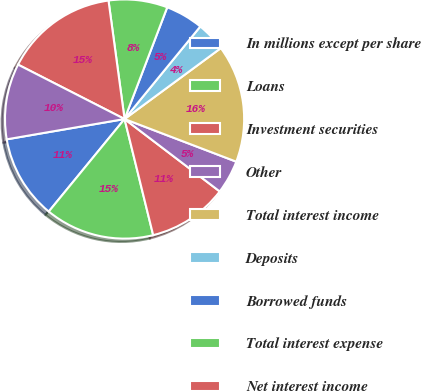<chart> <loc_0><loc_0><loc_500><loc_500><pie_chart><fcel>In millions except per share<fcel>Loans<fcel>Investment securities<fcel>Other<fcel>Total interest income<fcel>Deposits<fcel>Borrowed funds<fcel>Total interest expense<fcel>Net interest income<fcel>Asset management<nl><fcel>11.36%<fcel>14.77%<fcel>10.8%<fcel>4.55%<fcel>15.91%<fcel>3.98%<fcel>5.11%<fcel>7.95%<fcel>15.34%<fcel>10.23%<nl></chart> 